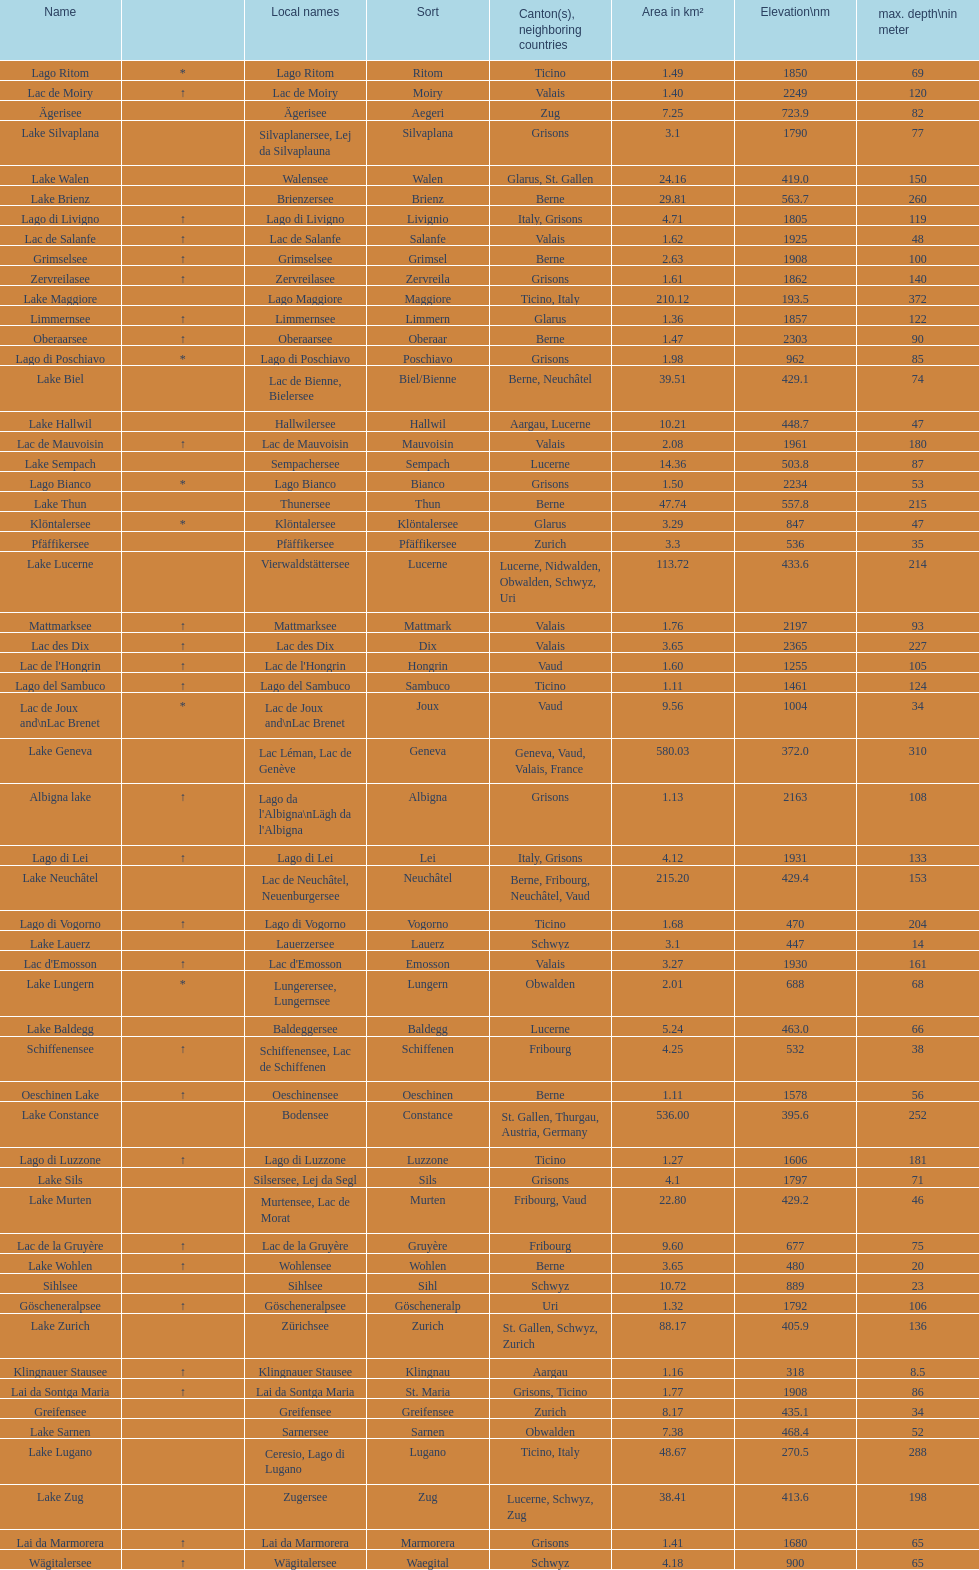What is the combined total depth of the three deepest lakes? 970. 